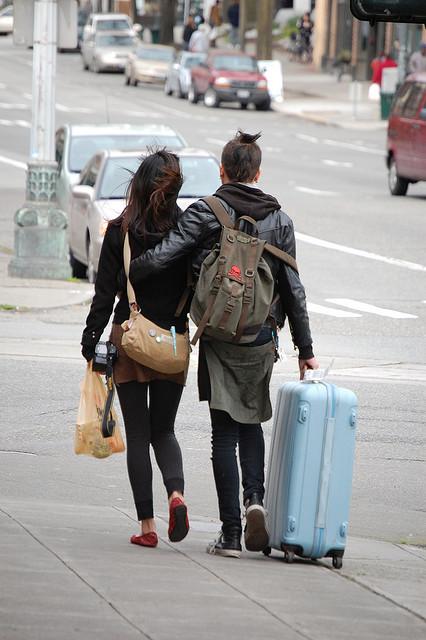Would the suitcase be considered large?
Write a very short answer. Yes. Which color is the suitcase?
Short answer required. Blue. Is the suitcase being carried?
Quick response, please. No. 